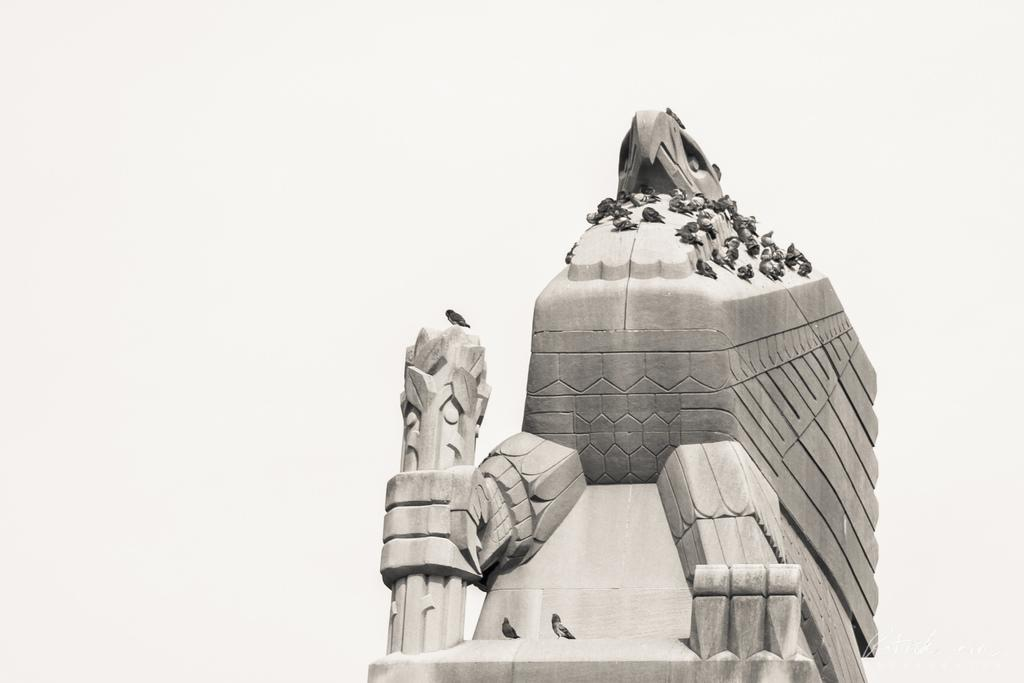What type of animals can be seen in the image? There are birds in the image. Where are the birds located? The birds are on a concrete structure. What type of belief system do the birds in the image follow? There is no indication in the image that the birds have any belief system, as they are simply birds on a concrete structure. 